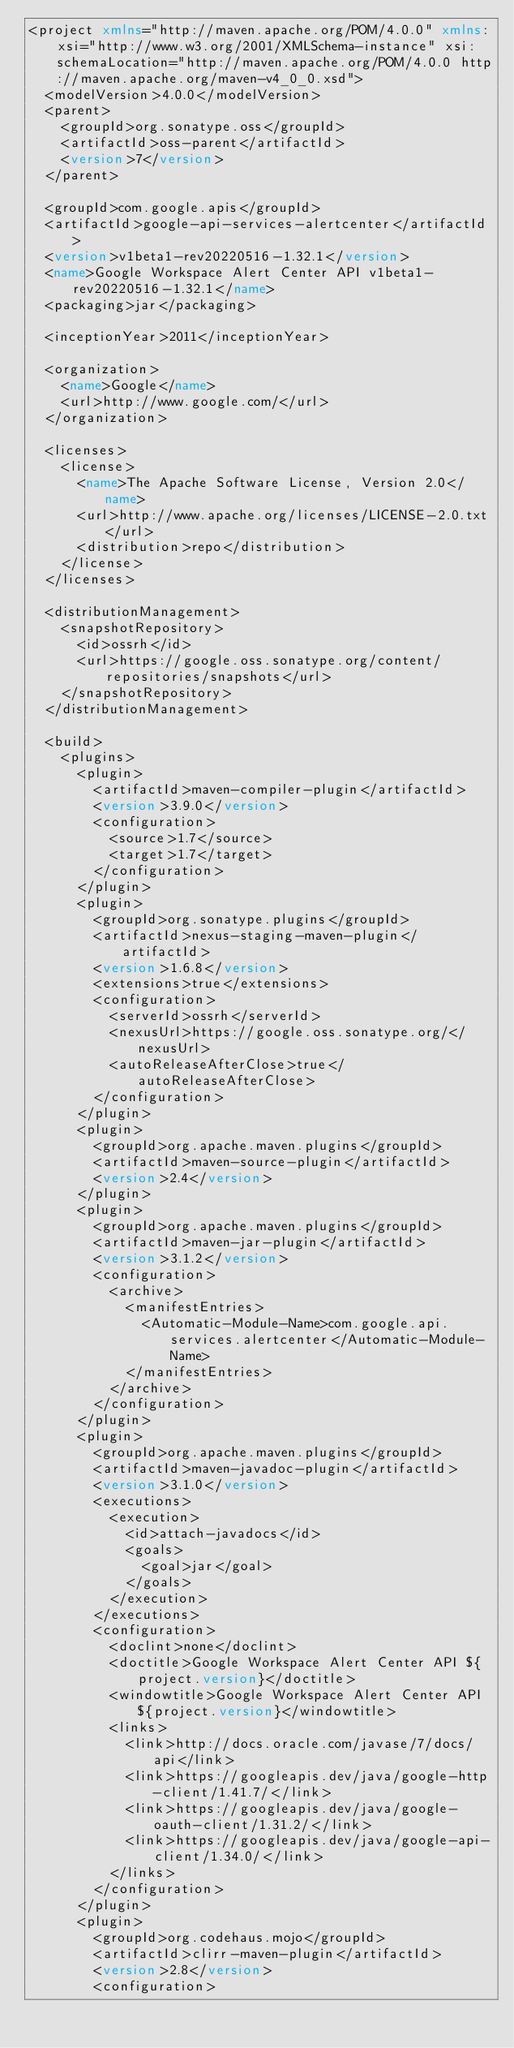Convert code to text. <code><loc_0><loc_0><loc_500><loc_500><_XML_><project xmlns="http://maven.apache.org/POM/4.0.0" xmlns:xsi="http://www.w3.org/2001/XMLSchema-instance" xsi:schemaLocation="http://maven.apache.org/POM/4.0.0 http://maven.apache.org/maven-v4_0_0.xsd">
  <modelVersion>4.0.0</modelVersion>
  <parent>
    <groupId>org.sonatype.oss</groupId>
    <artifactId>oss-parent</artifactId>
    <version>7</version>
  </parent>

  <groupId>com.google.apis</groupId>
  <artifactId>google-api-services-alertcenter</artifactId>
  <version>v1beta1-rev20220516-1.32.1</version>
  <name>Google Workspace Alert Center API v1beta1-rev20220516-1.32.1</name>
  <packaging>jar</packaging>

  <inceptionYear>2011</inceptionYear>

  <organization>
    <name>Google</name>
    <url>http://www.google.com/</url>
  </organization>

  <licenses>
    <license>
      <name>The Apache Software License, Version 2.0</name>
      <url>http://www.apache.org/licenses/LICENSE-2.0.txt</url>
      <distribution>repo</distribution>
    </license>
  </licenses>

  <distributionManagement>
    <snapshotRepository>
      <id>ossrh</id>
      <url>https://google.oss.sonatype.org/content/repositories/snapshots</url>
    </snapshotRepository>
  </distributionManagement>

  <build>
    <plugins>
      <plugin>
        <artifactId>maven-compiler-plugin</artifactId>
        <version>3.9.0</version>
        <configuration>
          <source>1.7</source>
          <target>1.7</target>
        </configuration>
      </plugin>
      <plugin>
        <groupId>org.sonatype.plugins</groupId>
        <artifactId>nexus-staging-maven-plugin</artifactId>
        <version>1.6.8</version>
        <extensions>true</extensions>
        <configuration>
          <serverId>ossrh</serverId>
          <nexusUrl>https://google.oss.sonatype.org/</nexusUrl>
          <autoReleaseAfterClose>true</autoReleaseAfterClose>
        </configuration>
      </plugin>
      <plugin>
        <groupId>org.apache.maven.plugins</groupId>
        <artifactId>maven-source-plugin</artifactId>
        <version>2.4</version>
      </plugin>
      <plugin>
        <groupId>org.apache.maven.plugins</groupId>
        <artifactId>maven-jar-plugin</artifactId>
        <version>3.1.2</version>
        <configuration>
          <archive>
            <manifestEntries>
              <Automatic-Module-Name>com.google.api.services.alertcenter</Automatic-Module-Name>
            </manifestEntries>
          </archive>
        </configuration>
      </plugin>
      <plugin>
        <groupId>org.apache.maven.plugins</groupId>
        <artifactId>maven-javadoc-plugin</artifactId>
        <version>3.1.0</version>
        <executions>
          <execution>
            <id>attach-javadocs</id>
            <goals>
              <goal>jar</goal>
            </goals>
          </execution>
        </executions>
        <configuration>
          <doclint>none</doclint>
          <doctitle>Google Workspace Alert Center API ${project.version}</doctitle>
          <windowtitle>Google Workspace Alert Center API ${project.version}</windowtitle>
          <links>
            <link>http://docs.oracle.com/javase/7/docs/api</link>
            <link>https://googleapis.dev/java/google-http-client/1.41.7/</link>
            <link>https://googleapis.dev/java/google-oauth-client/1.31.2/</link>
            <link>https://googleapis.dev/java/google-api-client/1.34.0/</link>
          </links>
        </configuration>
      </plugin>
      <plugin>
        <groupId>org.codehaus.mojo</groupId>
        <artifactId>clirr-maven-plugin</artifactId>
        <version>2.8</version>
        <configuration></code> 